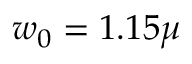<formula> <loc_0><loc_0><loc_500><loc_500>w _ { 0 } = 1 . 1 5 \mu</formula> 